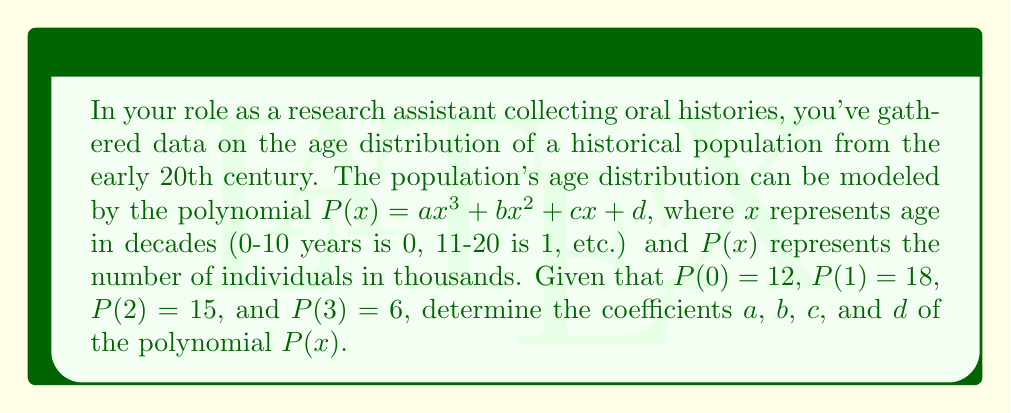Show me your answer to this math problem. To solve this problem, we'll use the given information to create a system of equations and then solve for the coefficients:

1) First, let's write out our four equations based on the given points:
   $P(0) = d = 12$
   $P(1) = a + b + c + d = 18$
   $P(2) = 8a + 4b + 2c + d = 15$
   $P(3) = 27a + 9b + 3c + d = 6$

2) From the first equation, we know that $d = 12$.

3) Substituting this into the second equation:
   $a + b + c + 12 = 18$
   $a + b + c = 6$ ... (Equation 1)

4) For the third equation:
   $8a + 4b + 2c + 12 = 15$
   $8a + 4b + 2c = 3$ ... (Equation 2)

5) For the fourth equation:
   $27a + 9b + 3c + 12 = 6$
   $27a + 9b + 3c = -6$ ... (Equation 3)

6) Now we have a system of three equations with three unknowns. Let's solve using elimination:
   Multiply Equation 1 by 2 and subtract from Equation 2:
   $6a + 2b = -3$ ... (Equation 4)

7) Multiply Equation 1 by 3 and subtract from Equation 3:
   $24a + 6b = -12$ ... (Equation 5)

8) Multiply Equation 4 by 3 and subtract from Equation 5:
   $6a = -3$
   $a = -0.5$

9) Substitute this back into Equation 4:
   $-3 + 2b = -3$
   $2b = 0$
   $b = 0$

10) Now substitute $a$ and $b$ into Equation 1:
    $-0.5 + 0 + c = 6$
    $c = 6.5$

Therefore, the coefficients are:
$a = -0.5$, $b = 0$, $c = 6.5$, and $d = 12$
Answer: $P(x) = -0.5x^3 + 6.5x + 12$ 